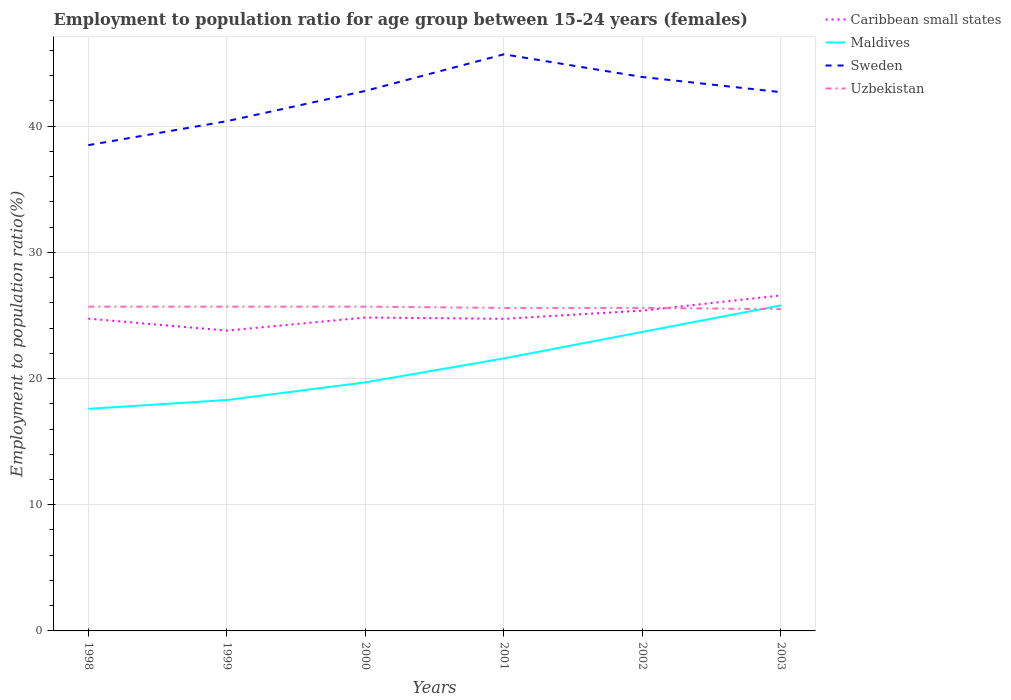Does the line corresponding to Maldives intersect with the line corresponding to Uzbekistan?
Make the answer very short. Yes. Across all years, what is the maximum employment to population ratio in Caribbean small states?
Keep it short and to the point. 23.8. What is the total employment to population ratio in Maldives in the graph?
Provide a succinct answer. -6.1. What is the difference between the highest and the second highest employment to population ratio in Caribbean small states?
Your response must be concise. 2.79. Is the employment to population ratio in Uzbekistan strictly greater than the employment to population ratio in Sweden over the years?
Provide a short and direct response. Yes. How many years are there in the graph?
Provide a succinct answer. 6. Does the graph contain any zero values?
Offer a terse response. No. Does the graph contain grids?
Make the answer very short. Yes. Where does the legend appear in the graph?
Provide a short and direct response. Top right. How are the legend labels stacked?
Offer a very short reply. Vertical. What is the title of the graph?
Keep it short and to the point. Employment to population ratio for age group between 15-24 years (females). Does "Luxembourg" appear as one of the legend labels in the graph?
Ensure brevity in your answer.  No. What is the label or title of the X-axis?
Provide a succinct answer. Years. What is the label or title of the Y-axis?
Your answer should be very brief. Employment to population ratio(%). What is the Employment to population ratio(%) of Caribbean small states in 1998?
Provide a short and direct response. 24.75. What is the Employment to population ratio(%) in Maldives in 1998?
Ensure brevity in your answer.  17.6. What is the Employment to population ratio(%) in Sweden in 1998?
Your answer should be very brief. 38.5. What is the Employment to population ratio(%) in Uzbekistan in 1998?
Your answer should be very brief. 25.7. What is the Employment to population ratio(%) in Caribbean small states in 1999?
Your answer should be compact. 23.8. What is the Employment to population ratio(%) of Maldives in 1999?
Provide a short and direct response. 18.3. What is the Employment to population ratio(%) of Sweden in 1999?
Ensure brevity in your answer.  40.4. What is the Employment to population ratio(%) of Uzbekistan in 1999?
Provide a short and direct response. 25.7. What is the Employment to population ratio(%) in Caribbean small states in 2000?
Your answer should be compact. 24.84. What is the Employment to population ratio(%) of Maldives in 2000?
Give a very brief answer. 19.7. What is the Employment to population ratio(%) of Sweden in 2000?
Keep it short and to the point. 42.8. What is the Employment to population ratio(%) of Uzbekistan in 2000?
Ensure brevity in your answer.  25.7. What is the Employment to population ratio(%) in Caribbean small states in 2001?
Keep it short and to the point. 24.74. What is the Employment to population ratio(%) in Maldives in 2001?
Provide a short and direct response. 21.6. What is the Employment to population ratio(%) of Sweden in 2001?
Provide a short and direct response. 45.7. What is the Employment to population ratio(%) of Uzbekistan in 2001?
Offer a terse response. 25.6. What is the Employment to population ratio(%) in Caribbean small states in 2002?
Ensure brevity in your answer.  25.38. What is the Employment to population ratio(%) in Maldives in 2002?
Your answer should be very brief. 23.7. What is the Employment to population ratio(%) in Sweden in 2002?
Offer a terse response. 43.9. What is the Employment to population ratio(%) of Uzbekistan in 2002?
Offer a very short reply. 25.6. What is the Employment to population ratio(%) of Caribbean small states in 2003?
Give a very brief answer. 26.59. What is the Employment to population ratio(%) in Maldives in 2003?
Offer a terse response. 25.8. What is the Employment to population ratio(%) in Sweden in 2003?
Provide a short and direct response. 42.7. Across all years, what is the maximum Employment to population ratio(%) of Caribbean small states?
Provide a succinct answer. 26.59. Across all years, what is the maximum Employment to population ratio(%) of Maldives?
Give a very brief answer. 25.8. Across all years, what is the maximum Employment to population ratio(%) in Sweden?
Offer a very short reply. 45.7. Across all years, what is the maximum Employment to population ratio(%) of Uzbekistan?
Keep it short and to the point. 25.7. Across all years, what is the minimum Employment to population ratio(%) in Caribbean small states?
Give a very brief answer. 23.8. Across all years, what is the minimum Employment to population ratio(%) of Maldives?
Your answer should be very brief. 17.6. Across all years, what is the minimum Employment to population ratio(%) in Sweden?
Provide a short and direct response. 38.5. What is the total Employment to population ratio(%) of Caribbean small states in the graph?
Make the answer very short. 150.1. What is the total Employment to population ratio(%) of Maldives in the graph?
Offer a very short reply. 126.7. What is the total Employment to population ratio(%) of Sweden in the graph?
Make the answer very short. 254. What is the total Employment to population ratio(%) in Uzbekistan in the graph?
Ensure brevity in your answer.  153.8. What is the difference between the Employment to population ratio(%) in Caribbean small states in 1998 and that in 1999?
Keep it short and to the point. 0.95. What is the difference between the Employment to population ratio(%) of Maldives in 1998 and that in 1999?
Make the answer very short. -0.7. What is the difference between the Employment to population ratio(%) in Caribbean small states in 1998 and that in 2000?
Keep it short and to the point. -0.09. What is the difference between the Employment to population ratio(%) in Maldives in 1998 and that in 2000?
Your answer should be compact. -2.1. What is the difference between the Employment to population ratio(%) of Uzbekistan in 1998 and that in 2000?
Your response must be concise. 0. What is the difference between the Employment to population ratio(%) of Caribbean small states in 1998 and that in 2001?
Offer a very short reply. 0.01. What is the difference between the Employment to population ratio(%) of Maldives in 1998 and that in 2001?
Keep it short and to the point. -4. What is the difference between the Employment to population ratio(%) in Sweden in 1998 and that in 2001?
Your answer should be compact. -7.2. What is the difference between the Employment to population ratio(%) of Uzbekistan in 1998 and that in 2001?
Offer a very short reply. 0.1. What is the difference between the Employment to population ratio(%) in Caribbean small states in 1998 and that in 2002?
Your answer should be compact. -0.64. What is the difference between the Employment to population ratio(%) of Maldives in 1998 and that in 2002?
Your answer should be compact. -6.1. What is the difference between the Employment to population ratio(%) of Sweden in 1998 and that in 2002?
Give a very brief answer. -5.4. What is the difference between the Employment to population ratio(%) of Uzbekistan in 1998 and that in 2002?
Offer a very short reply. 0.1. What is the difference between the Employment to population ratio(%) of Caribbean small states in 1998 and that in 2003?
Your answer should be very brief. -1.84. What is the difference between the Employment to population ratio(%) of Uzbekistan in 1998 and that in 2003?
Make the answer very short. 0.2. What is the difference between the Employment to population ratio(%) in Caribbean small states in 1999 and that in 2000?
Give a very brief answer. -1.04. What is the difference between the Employment to population ratio(%) in Caribbean small states in 1999 and that in 2001?
Provide a succinct answer. -0.94. What is the difference between the Employment to population ratio(%) in Sweden in 1999 and that in 2001?
Provide a succinct answer. -5.3. What is the difference between the Employment to population ratio(%) of Caribbean small states in 1999 and that in 2002?
Make the answer very short. -1.58. What is the difference between the Employment to population ratio(%) of Maldives in 1999 and that in 2002?
Your answer should be very brief. -5.4. What is the difference between the Employment to population ratio(%) of Sweden in 1999 and that in 2002?
Offer a very short reply. -3.5. What is the difference between the Employment to population ratio(%) in Caribbean small states in 1999 and that in 2003?
Your response must be concise. -2.79. What is the difference between the Employment to population ratio(%) in Sweden in 1999 and that in 2003?
Offer a terse response. -2.3. What is the difference between the Employment to population ratio(%) in Uzbekistan in 1999 and that in 2003?
Offer a terse response. 0.2. What is the difference between the Employment to population ratio(%) of Caribbean small states in 2000 and that in 2001?
Your answer should be very brief. 0.1. What is the difference between the Employment to population ratio(%) of Maldives in 2000 and that in 2001?
Provide a short and direct response. -1.9. What is the difference between the Employment to population ratio(%) in Sweden in 2000 and that in 2001?
Provide a succinct answer. -2.9. What is the difference between the Employment to population ratio(%) of Uzbekistan in 2000 and that in 2001?
Your answer should be very brief. 0.1. What is the difference between the Employment to population ratio(%) in Caribbean small states in 2000 and that in 2002?
Your answer should be very brief. -0.55. What is the difference between the Employment to population ratio(%) of Caribbean small states in 2000 and that in 2003?
Your answer should be compact. -1.75. What is the difference between the Employment to population ratio(%) in Sweden in 2000 and that in 2003?
Ensure brevity in your answer.  0.1. What is the difference between the Employment to population ratio(%) of Caribbean small states in 2001 and that in 2002?
Provide a short and direct response. -0.65. What is the difference between the Employment to population ratio(%) in Uzbekistan in 2001 and that in 2002?
Ensure brevity in your answer.  0. What is the difference between the Employment to population ratio(%) in Caribbean small states in 2001 and that in 2003?
Keep it short and to the point. -1.85. What is the difference between the Employment to population ratio(%) of Caribbean small states in 2002 and that in 2003?
Make the answer very short. -1.21. What is the difference between the Employment to population ratio(%) of Uzbekistan in 2002 and that in 2003?
Make the answer very short. 0.1. What is the difference between the Employment to population ratio(%) of Caribbean small states in 1998 and the Employment to population ratio(%) of Maldives in 1999?
Provide a succinct answer. 6.45. What is the difference between the Employment to population ratio(%) in Caribbean small states in 1998 and the Employment to population ratio(%) in Sweden in 1999?
Offer a terse response. -15.65. What is the difference between the Employment to population ratio(%) of Caribbean small states in 1998 and the Employment to population ratio(%) of Uzbekistan in 1999?
Provide a succinct answer. -0.95. What is the difference between the Employment to population ratio(%) in Maldives in 1998 and the Employment to population ratio(%) in Sweden in 1999?
Your response must be concise. -22.8. What is the difference between the Employment to population ratio(%) of Maldives in 1998 and the Employment to population ratio(%) of Uzbekistan in 1999?
Provide a short and direct response. -8.1. What is the difference between the Employment to population ratio(%) in Sweden in 1998 and the Employment to population ratio(%) in Uzbekistan in 1999?
Provide a succinct answer. 12.8. What is the difference between the Employment to population ratio(%) of Caribbean small states in 1998 and the Employment to population ratio(%) of Maldives in 2000?
Your response must be concise. 5.05. What is the difference between the Employment to population ratio(%) in Caribbean small states in 1998 and the Employment to population ratio(%) in Sweden in 2000?
Offer a terse response. -18.05. What is the difference between the Employment to population ratio(%) in Caribbean small states in 1998 and the Employment to population ratio(%) in Uzbekistan in 2000?
Keep it short and to the point. -0.95. What is the difference between the Employment to population ratio(%) of Maldives in 1998 and the Employment to population ratio(%) of Sweden in 2000?
Make the answer very short. -25.2. What is the difference between the Employment to population ratio(%) in Maldives in 1998 and the Employment to population ratio(%) in Uzbekistan in 2000?
Keep it short and to the point. -8.1. What is the difference between the Employment to population ratio(%) in Caribbean small states in 1998 and the Employment to population ratio(%) in Maldives in 2001?
Ensure brevity in your answer.  3.15. What is the difference between the Employment to population ratio(%) in Caribbean small states in 1998 and the Employment to population ratio(%) in Sweden in 2001?
Make the answer very short. -20.95. What is the difference between the Employment to population ratio(%) of Caribbean small states in 1998 and the Employment to population ratio(%) of Uzbekistan in 2001?
Provide a succinct answer. -0.85. What is the difference between the Employment to population ratio(%) in Maldives in 1998 and the Employment to population ratio(%) in Sweden in 2001?
Provide a succinct answer. -28.1. What is the difference between the Employment to population ratio(%) in Caribbean small states in 1998 and the Employment to population ratio(%) in Maldives in 2002?
Give a very brief answer. 1.05. What is the difference between the Employment to population ratio(%) of Caribbean small states in 1998 and the Employment to population ratio(%) of Sweden in 2002?
Your answer should be very brief. -19.15. What is the difference between the Employment to population ratio(%) in Caribbean small states in 1998 and the Employment to population ratio(%) in Uzbekistan in 2002?
Give a very brief answer. -0.85. What is the difference between the Employment to population ratio(%) in Maldives in 1998 and the Employment to population ratio(%) in Sweden in 2002?
Provide a short and direct response. -26.3. What is the difference between the Employment to population ratio(%) in Sweden in 1998 and the Employment to population ratio(%) in Uzbekistan in 2002?
Your response must be concise. 12.9. What is the difference between the Employment to population ratio(%) in Caribbean small states in 1998 and the Employment to population ratio(%) in Maldives in 2003?
Provide a succinct answer. -1.05. What is the difference between the Employment to population ratio(%) of Caribbean small states in 1998 and the Employment to population ratio(%) of Sweden in 2003?
Offer a terse response. -17.95. What is the difference between the Employment to population ratio(%) in Caribbean small states in 1998 and the Employment to population ratio(%) in Uzbekistan in 2003?
Provide a short and direct response. -0.75. What is the difference between the Employment to population ratio(%) in Maldives in 1998 and the Employment to population ratio(%) in Sweden in 2003?
Provide a short and direct response. -25.1. What is the difference between the Employment to population ratio(%) of Maldives in 1998 and the Employment to population ratio(%) of Uzbekistan in 2003?
Make the answer very short. -7.9. What is the difference between the Employment to population ratio(%) in Sweden in 1998 and the Employment to population ratio(%) in Uzbekistan in 2003?
Offer a terse response. 13. What is the difference between the Employment to population ratio(%) of Caribbean small states in 1999 and the Employment to population ratio(%) of Maldives in 2000?
Offer a terse response. 4.1. What is the difference between the Employment to population ratio(%) in Caribbean small states in 1999 and the Employment to population ratio(%) in Sweden in 2000?
Provide a short and direct response. -19. What is the difference between the Employment to population ratio(%) in Caribbean small states in 1999 and the Employment to population ratio(%) in Uzbekistan in 2000?
Make the answer very short. -1.9. What is the difference between the Employment to population ratio(%) of Maldives in 1999 and the Employment to population ratio(%) of Sweden in 2000?
Your answer should be very brief. -24.5. What is the difference between the Employment to population ratio(%) of Caribbean small states in 1999 and the Employment to population ratio(%) of Maldives in 2001?
Ensure brevity in your answer.  2.2. What is the difference between the Employment to population ratio(%) of Caribbean small states in 1999 and the Employment to population ratio(%) of Sweden in 2001?
Keep it short and to the point. -21.9. What is the difference between the Employment to population ratio(%) of Caribbean small states in 1999 and the Employment to population ratio(%) of Uzbekistan in 2001?
Keep it short and to the point. -1.8. What is the difference between the Employment to population ratio(%) of Maldives in 1999 and the Employment to population ratio(%) of Sweden in 2001?
Make the answer very short. -27.4. What is the difference between the Employment to population ratio(%) of Caribbean small states in 1999 and the Employment to population ratio(%) of Maldives in 2002?
Your answer should be compact. 0.1. What is the difference between the Employment to population ratio(%) of Caribbean small states in 1999 and the Employment to population ratio(%) of Sweden in 2002?
Ensure brevity in your answer.  -20.1. What is the difference between the Employment to population ratio(%) of Caribbean small states in 1999 and the Employment to population ratio(%) of Uzbekistan in 2002?
Provide a succinct answer. -1.8. What is the difference between the Employment to population ratio(%) in Maldives in 1999 and the Employment to population ratio(%) in Sweden in 2002?
Give a very brief answer. -25.6. What is the difference between the Employment to population ratio(%) of Sweden in 1999 and the Employment to population ratio(%) of Uzbekistan in 2002?
Offer a very short reply. 14.8. What is the difference between the Employment to population ratio(%) of Caribbean small states in 1999 and the Employment to population ratio(%) of Maldives in 2003?
Your answer should be very brief. -2. What is the difference between the Employment to population ratio(%) of Caribbean small states in 1999 and the Employment to population ratio(%) of Sweden in 2003?
Your response must be concise. -18.9. What is the difference between the Employment to population ratio(%) in Caribbean small states in 1999 and the Employment to population ratio(%) in Uzbekistan in 2003?
Your answer should be compact. -1.7. What is the difference between the Employment to population ratio(%) in Maldives in 1999 and the Employment to population ratio(%) in Sweden in 2003?
Your response must be concise. -24.4. What is the difference between the Employment to population ratio(%) of Maldives in 1999 and the Employment to population ratio(%) of Uzbekistan in 2003?
Your response must be concise. -7.2. What is the difference between the Employment to population ratio(%) in Sweden in 1999 and the Employment to population ratio(%) in Uzbekistan in 2003?
Provide a short and direct response. 14.9. What is the difference between the Employment to population ratio(%) of Caribbean small states in 2000 and the Employment to population ratio(%) of Maldives in 2001?
Offer a terse response. 3.24. What is the difference between the Employment to population ratio(%) of Caribbean small states in 2000 and the Employment to population ratio(%) of Sweden in 2001?
Keep it short and to the point. -20.86. What is the difference between the Employment to population ratio(%) of Caribbean small states in 2000 and the Employment to population ratio(%) of Uzbekistan in 2001?
Offer a terse response. -0.76. What is the difference between the Employment to population ratio(%) in Maldives in 2000 and the Employment to population ratio(%) in Sweden in 2001?
Offer a very short reply. -26. What is the difference between the Employment to population ratio(%) in Caribbean small states in 2000 and the Employment to population ratio(%) in Maldives in 2002?
Make the answer very short. 1.14. What is the difference between the Employment to population ratio(%) of Caribbean small states in 2000 and the Employment to population ratio(%) of Sweden in 2002?
Offer a very short reply. -19.06. What is the difference between the Employment to population ratio(%) of Caribbean small states in 2000 and the Employment to population ratio(%) of Uzbekistan in 2002?
Your answer should be compact. -0.76. What is the difference between the Employment to population ratio(%) in Maldives in 2000 and the Employment to population ratio(%) in Sweden in 2002?
Ensure brevity in your answer.  -24.2. What is the difference between the Employment to population ratio(%) of Maldives in 2000 and the Employment to population ratio(%) of Uzbekistan in 2002?
Provide a short and direct response. -5.9. What is the difference between the Employment to population ratio(%) of Sweden in 2000 and the Employment to population ratio(%) of Uzbekistan in 2002?
Offer a terse response. 17.2. What is the difference between the Employment to population ratio(%) in Caribbean small states in 2000 and the Employment to population ratio(%) in Maldives in 2003?
Your answer should be compact. -0.96. What is the difference between the Employment to population ratio(%) in Caribbean small states in 2000 and the Employment to population ratio(%) in Sweden in 2003?
Your response must be concise. -17.86. What is the difference between the Employment to population ratio(%) in Caribbean small states in 2000 and the Employment to population ratio(%) in Uzbekistan in 2003?
Give a very brief answer. -0.66. What is the difference between the Employment to population ratio(%) of Maldives in 2000 and the Employment to population ratio(%) of Sweden in 2003?
Provide a succinct answer. -23. What is the difference between the Employment to population ratio(%) of Sweden in 2000 and the Employment to population ratio(%) of Uzbekistan in 2003?
Give a very brief answer. 17.3. What is the difference between the Employment to population ratio(%) of Caribbean small states in 2001 and the Employment to population ratio(%) of Maldives in 2002?
Give a very brief answer. 1.04. What is the difference between the Employment to population ratio(%) of Caribbean small states in 2001 and the Employment to population ratio(%) of Sweden in 2002?
Keep it short and to the point. -19.16. What is the difference between the Employment to population ratio(%) of Caribbean small states in 2001 and the Employment to population ratio(%) of Uzbekistan in 2002?
Keep it short and to the point. -0.86. What is the difference between the Employment to population ratio(%) in Maldives in 2001 and the Employment to population ratio(%) in Sweden in 2002?
Keep it short and to the point. -22.3. What is the difference between the Employment to population ratio(%) in Sweden in 2001 and the Employment to population ratio(%) in Uzbekistan in 2002?
Your answer should be very brief. 20.1. What is the difference between the Employment to population ratio(%) in Caribbean small states in 2001 and the Employment to population ratio(%) in Maldives in 2003?
Your answer should be compact. -1.06. What is the difference between the Employment to population ratio(%) of Caribbean small states in 2001 and the Employment to population ratio(%) of Sweden in 2003?
Give a very brief answer. -17.96. What is the difference between the Employment to population ratio(%) of Caribbean small states in 2001 and the Employment to population ratio(%) of Uzbekistan in 2003?
Ensure brevity in your answer.  -0.76. What is the difference between the Employment to population ratio(%) in Maldives in 2001 and the Employment to population ratio(%) in Sweden in 2003?
Offer a very short reply. -21.1. What is the difference between the Employment to population ratio(%) of Sweden in 2001 and the Employment to population ratio(%) of Uzbekistan in 2003?
Provide a short and direct response. 20.2. What is the difference between the Employment to population ratio(%) of Caribbean small states in 2002 and the Employment to population ratio(%) of Maldives in 2003?
Make the answer very short. -0.42. What is the difference between the Employment to population ratio(%) of Caribbean small states in 2002 and the Employment to population ratio(%) of Sweden in 2003?
Provide a succinct answer. -17.32. What is the difference between the Employment to population ratio(%) in Caribbean small states in 2002 and the Employment to population ratio(%) in Uzbekistan in 2003?
Your answer should be very brief. -0.12. What is the difference between the Employment to population ratio(%) in Maldives in 2002 and the Employment to population ratio(%) in Sweden in 2003?
Offer a terse response. -19. What is the difference between the Employment to population ratio(%) of Maldives in 2002 and the Employment to population ratio(%) of Uzbekistan in 2003?
Give a very brief answer. -1.8. What is the difference between the Employment to population ratio(%) of Sweden in 2002 and the Employment to population ratio(%) of Uzbekistan in 2003?
Provide a succinct answer. 18.4. What is the average Employment to population ratio(%) in Caribbean small states per year?
Your response must be concise. 25.02. What is the average Employment to population ratio(%) in Maldives per year?
Offer a terse response. 21.12. What is the average Employment to population ratio(%) of Sweden per year?
Ensure brevity in your answer.  42.33. What is the average Employment to population ratio(%) of Uzbekistan per year?
Your answer should be very brief. 25.63. In the year 1998, what is the difference between the Employment to population ratio(%) in Caribbean small states and Employment to population ratio(%) in Maldives?
Offer a terse response. 7.15. In the year 1998, what is the difference between the Employment to population ratio(%) of Caribbean small states and Employment to population ratio(%) of Sweden?
Your response must be concise. -13.75. In the year 1998, what is the difference between the Employment to population ratio(%) of Caribbean small states and Employment to population ratio(%) of Uzbekistan?
Your answer should be compact. -0.95. In the year 1998, what is the difference between the Employment to population ratio(%) in Maldives and Employment to population ratio(%) in Sweden?
Ensure brevity in your answer.  -20.9. In the year 1998, what is the difference between the Employment to population ratio(%) of Maldives and Employment to population ratio(%) of Uzbekistan?
Offer a very short reply. -8.1. In the year 1999, what is the difference between the Employment to population ratio(%) in Caribbean small states and Employment to population ratio(%) in Maldives?
Offer a terse response. 5.5. In the year 1999, what is the difference between the Employment to population ratio(%) in Caribbean small states and Employment to population ratio(%) in Sweden?
Provide a short and direct response. -16.6. In the year 1999, what is the difference between the Employment to population ratio(%) in Caribbean small states and Employment to population ratio(%) in Uzbekistan?
Provide a short and direct response. -1.9. In the year 1999, what is the difference between the Employment to population ratio(%) of Maldives and Employment to population ratio(%) of Sweden?
Offer a very short reply. -22.1. In the year 1999, what is the difference between the Employment to population ratio(%) of Sweden and Employment to population ratio(%) of Uzbekistan?
Make the answer very short. 14.7. In the year 2000, what is the difference between the Employment to population ratio(%) in Caribbean small states and Employment to population ratio(%) in Maldives?
Make the answer very short. 5.14. In the year 2000, what is the difference between the Employment to population ratio(%) of Caribbean small states and Employment to population ratio(%) of Sweden?
Ensure brevity in your answer.  -17.96. In the year 2000, what is the difference between the Employment to population ratio(%) of Caribbean small states and Employment to population ratio(%) of Uzbekistan?
Ensure brevity in your answer.  -0.86. In the year 2000, what is the difference between the Employment to population ratio(%) in Maldives and Employment to population ratio(%) in Sweden?
Offer a very short reply. -23.1. In the year 2001, what is the difference between the Employment to population ratio(%) of Caribbean small states and Employment to population ratio(%) of Maldives?
Your response must be concise. 3.14. In the year 2001, what is the difference between the Employment to population ratio(%) of Caribbean small states and Employment to population ratio(%) of Sweden?
Give a very brief answer. -20.96. In the year 2001, what is the difference between the Employment to population ratio(%) of Caribbean small states and Employment to population ratio(%) of Uzbekistan?
Your response must be concise. -0.86. In the year 2001, what is the difference between the Employment to population ratio(%) in Maldives and Employment to population ratio(%) in Sweden?
Provide a short and direct response. -24.1. In the year 2001, what is the difference between the Employment to population ratio(%) of Sweden and Employment to population ratio(%) of Uzbekistan?
Provide a short and direct response. 20.1. In the year 2002, what is the difference between the Employment to population ratio(%) in Caribbean small states and Employment to population ratio(%) in Maldives?
Keep it short and to the point. 1.68. In the year 2002, what is the difference between the Employment to population ratio(%) of Caribbean small states and Employment to population ratio(%) of Sweden?
Keep it short and to the point. -18.52. In the year 2002, what is the difference between the Employment to population ratio(%) in Caribbean small states and Employment to population ratio(%) in Uzbekistan?
Provide a short and direct response. -0.22. In the year 2002, what is the difference between the Employment to population ratio(%) in Maldives and Employment to population ratio(%) in Sweden?
Provide a succinct answer. -20.2. In the year 2003, what is the difference between the Employment to population ratio(%) in Caribbean small states and Employment to population ratio(%) in Maldives?
Your response must be concise. 0.79. In the year 2003, what is the difference between the Employment to population ratio(%) in Caribbean small states and Employment to population ratio(%) in Sweden?
Ensure brevity in your answer.  -16.11. In the year 2003, what is the difference between the Employment to population ratio(%) in Caribbean small states and Employment to population ratio(%) in Uzbekistan?
Offer a very short reply. 1.09. In the year 2003, what is the difference between the Employment to population ratio(%) of Maldives and Employment to population ratio(%) of Sweden?
Provide a succinct answer. -16.9. In the year 2003, what is the difference between the Employment to population ratio(%) of Sweden and Employment to population ratio(%) of Uzbekistan?
Your answer should be very brief. 17.2. What is the ratio of the Employment to population ratio(%) in Caribbean small states in 1998 to that in 1999?
Make the answer very short. 1.04. What is the ratio of the Employment to population ratio(%) of Maldives in 1998 to that in 1999?
Your answer should be compact. 0.96. What is the ratio of the Employment to population ratio(%) in Sweden in 1998 to that in 1999?
Your answer should be very brief. 0.95. What is the ratio of the Employment to population ratio(%) in Maldives in 1998 to that in 2000?
Provide a short and direct response. 0.89. What is the ratio of the Employment to population ratio(%) of Sweden in 1998 to that in 2000?
Offer a terse response. 0.9. What is the ratio of the Employment to population ratio(%) in Uzbekistan in 1998 to that in 2000?
Offer a terse response. 1. What is the ratio of the Employment to population ratio(%) of Caribbean small states in 1998 to that in 2001?
Offer a very short reply. 1. What is the ratio of the Employment to population ratio(%) of Maldives in 1998 to that in 2001?
Ensure brevity in your answer.  0.81. What is the ratio of the Employment to population ratio(%) in Sweden in 1998 to that in 2001?
Keep it short and to the point. 0.84. What is the ratio of the Employment to population ratio(%) of Uzbekistan in 1998 to that in 2001?
Your answer should be compact. 1. What is the ratio of the Employment to population ratio(%) in Caribbean small states in 1998 to that in 2002?
Offer a terse response. 0.97. What is the ratio of the Employment to population ratio(%) in Maldives in 1998 to that in 2002?
Make the answer very short. 0.74. What is the ratio of the Employment to population ratio(%) in Sweden in 1998 to that in 2002?
Your response must be concise. 0.88. What is the ratio of the Employment to population ratio(%) in Uzbekistan in 1998 to that in 2002?
Offer a terse response. 1. What is the ratio of the Employment to population ratio(%) in Caribbean small states in 1998 to that in 2003?
Provide a succinct answer. 0.93. What is the ratio of the Employment to population ratio(%) in Maldives in 1998 to that in 2003?
Give a very brief answer. 0.68. What is the ratio of the Employment to population ratio(%) in Sweden in 1998 to that in 2003?
Provide a short and direct response. 0.9. What is the ratio of the Employment to population ratio(%) in Caribbean small states in 1999 to that in 2000?
Your answer should be compact. 0.96. What is the ratio of the Employment to population ratio(%) in Maldives in 1999 to that in 2000?
Your answer should be compact. 0.93. What is the ratio of the Employment to population ratio(%) in Sweden in 1999 to that in 2000?
Your answer should be very brief. 0.94. What is the ratio of the Employment to population ratio(%) of Uzbekistan in 1999 to that in 2000?
Give a very brief answer. 1. What is the ratio of the Employment to population ratio(%) of Caribbean small states in 1999 to that in 2001?
Ensure brevity in your answer.  0.96. What is the ratio of the Employment to population ratio(%) of Maldives in 1999 to that in 2001?
Your response must be concise. 0.85. What is the ratio of the Employment to population ratio(%) of Sweden in 1999 to that in 2001?
Your response must be concise. 0.88. What is the ratio of the Employment to population ratio(%) in Caribbean small states in 1999 to that in 2002?
Offer a terse response. 0.94. What is the ratio of the Employment to population ratio(%) of Maldives in 1999 to that in 2002?
Your response must be concise. 0.77. What is the ratio of the Employment to population ratio(%) in Sweden in 1999 to that in 2002?
Ensure brevity in your answer.  0.92. What is the ratio of the Employment to population ratio(%) of Caribbean small states in 1999 to that in 2003?
Your answer should be very brief. 0.9. What is the ratio of the Employment to population ratio(%) in Maldives in 1999 to that in 2003?
Give a very brief answer. 0.71. What is the ratio of the Employment to population ratio(%) of Sweden in 1999 to that in 2003?
Ensure brevity in your answer.  0.95. What is the ratio of the Employment to population ratio(%) in Uzbekistan in 1999 to that in 2003?
Ensure brevity in your answer.  1.01. What is the ratio of the Employment to population ratio(%) in Caribbean small states in 2000 to that in 2001?
Give a very brief answer. 1. What is the ratio of the Employment to population ratio(%) of Maldives in 2000 to that in 2001?
Your answer should be compact. 0.91. What is the ratio of the Employment to population ratio(%) of Sweden in 2000 to that in 2001?
Your answer should be compact. 0.94. What is the ratio of the Employment to population ratio(%) in Caribbean small states in 2000 to that in 2002?
Provide a succinct answer. 0.98. What is the ratio of the Employment to population ratio(%) of Maldives in 2000 to that in 2002?
Make the answer very short. 0.83. What is the ratio of the Employment to population ratio(%) of Sweden in 2000 to that in 2002?
Offer a very short reply. 0.97. What is the ratio of the Employment to population ratio(%) of Caribbean small states in 2000 to that in 2003?
Give a very brief answer. 0.93. What is the ratio of the Employment to population ratio(%) in Maldives in 2000 to that in 2003?
Ensure brevity in your answer.  0.76. What is the ratio of the Employment to population ratio(%) in Sweden in 2000 to that in 2003?
Your response must be concise. 1. What is the ratio of the Employment to population ratio(%) of Caribbean small states in 2001 to that in 2002?
Provide a succinct answer. 0.97. What is the ratio of the Employment to population ratio(%) of Maldives in 2001 to that in 2002?
Ensure brevity in your answer.  0.91. What is the ratio of the Employment to population ratio(%) in Sweden in 2001 to that in 2002?
Keep it short and to the point. 1.04. What is the ratio of the Employment to population ratio(%) of Uzbekistan in 2001 to that in 2002?
Make the answer very short. 1. What is the ratio of the Employment to population ratio(%) in Caribbean small states in 2001 to that in 2003?
Offer a very short reply. 0.93. What is the ratio of the Employment to population ratio(%) of Maldives in 2001 to that in 2003?
Keep it short and to the point. 0.84. What is the ratio of the Employment to population ratio(%) in Sweden in 2001 to that in 2003?
Provide a succinct answer. 1.07. What is the ratio of the Employment to population ratio(%) in Uzbekistan in 2001 to that in 2003?
Keep it short and to the point. 1. What is the ratio of the Employment to population ratio(%) of Caribbean small states in 2002 to that in 2003?
Provide a succinct answer. 0.95. What is the ratio of the Employment to population ratio(%) in Maldives in 2002 to that in 2003?
Offer a very short reply. 0.92. What is the ratio of the Employment to population ratio(%) of Sweden in 2002 to that in 2003?
Ensure brevity in your answer.  1.03. What is the difference between the highest and the second highest Employment to population ratio(%) of Caribbean small states?
Ensure brevity in your answer.  1.21. What is the difference between the highest and the second highest Employment to population ratio(%) of Maldives?
Give a very brief answer. 2.1. What is the difference between the highest and the lowest Employment to population ratio(%) of Caribbean small states?
Keep it short and to the point. 2.79. What is the difference between the highest and the lowest Employment to population ratio(%) in Sweden?
Offer a very short reply. 7.2. 